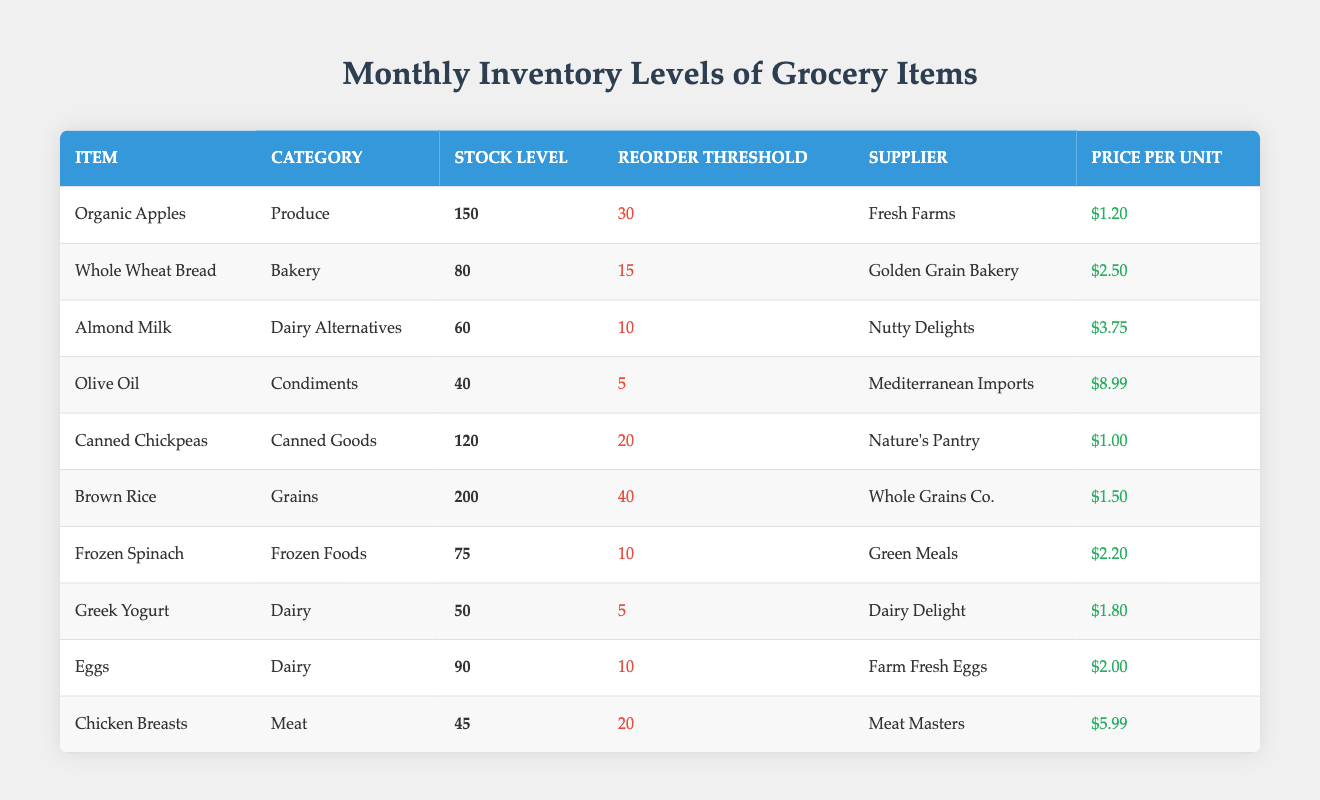What is the stock level of Organic Apples? The stock level for Organic Apples is listed directly in the table under the "Stock Level" column next to its item name.
Answer: 150 What is the reorder threshold for Chicken Breasts? The reorder threshold for Chicken Breasts can be found in the table under the "Reorder Threshold" column beside the Chicken Breasts row.
Answer: 20 Which item has the highest price per unit? By comparing the "Price Per Unit" column values, Olive Oil at $8.99 has the highest price.
Answer: Olive Oil How many items have a stock level below 60? Looking through the "Stock Level" column, only the Greek Yogurt and Almond Milk have stock levels of 50 and 60, respectively. Therefore, there is one item below 60.
Answer: 1 What is the total stock level of all Dairy items? The Dairy items listed are Almond Milk (60), Greek Yogurt (50), and Eggs (90). Adding these gives a total of 60 + 50 + 90 = 200.
Answer: 200 Is there an item with a stock level equal to its reorder threshold? The table shows that Greek Yogurt (50 stock, 5 reorder) and Olive Oil (40 stock, 5 reorder) do not satisfy this condition. Thus, the answer is no.
Answer: No What is the average price per unit of all Canned Goods? The price per unit for the Canned Goods (Canned Chickpeas at $1.00) only yields 1 item; thus the average price equals $1.00.
Answer: 1.00 What items fall under the category of Frozen Foods and also have a stock level above their reorder threshold? From the table, the Frozen Food item is Frozen Spinach, with a stock level of 75 which is higher than the reorder threshold of 10. This satisfies the query criteria.
Answer: Frozen Spinach How many items have a stock level that is greater than or equal to 80? By examining the stock levels: Organic Apples (150), Whole Wheat Bread (80), Brown Rice (200), and Canned Chickpeas (120) yield a total of four items meeting that requirement.
Answer: 4 